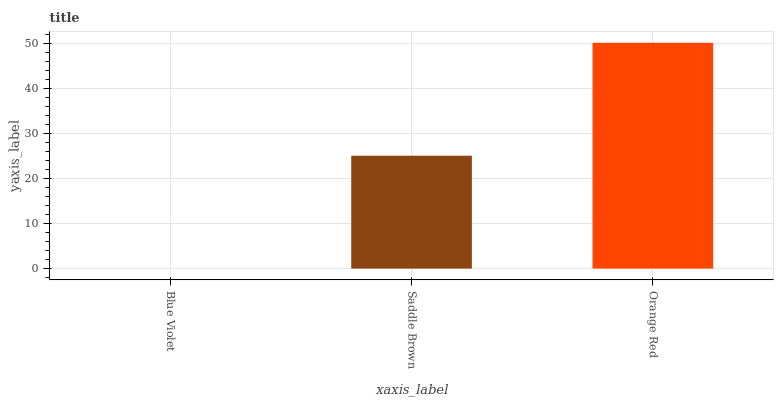Is Blue Violet the minimum?
Answer yes or no. Yes. Is Orange Red the maximum?
Answer yes or no. Yes. Is Saddle Brown the minimum?
Answer yes or no. No. Is Saddle Brown the maximum?
Answer yes or no. No. Is Saddle Brown greater than Blue Violet?
Answer yes or no. Yes. Is Blue Violet less than Saddle Brown?
Answer yes or no. Yes. Is Blue Violet greater than Saddle Brown?
Answer yes or no. No. Is Saddle Brown less than Blue Violet?
Answer yes or no. No. Is Saddle Brown the high median?
Answer yes or no. Yes. Is Saddle Brown the low median?
Answer yes or no. Yes. Is Orange Red the high median?
Answer yes or no. No. Is Blue Violet the low median?
Answer yes or no. No. 